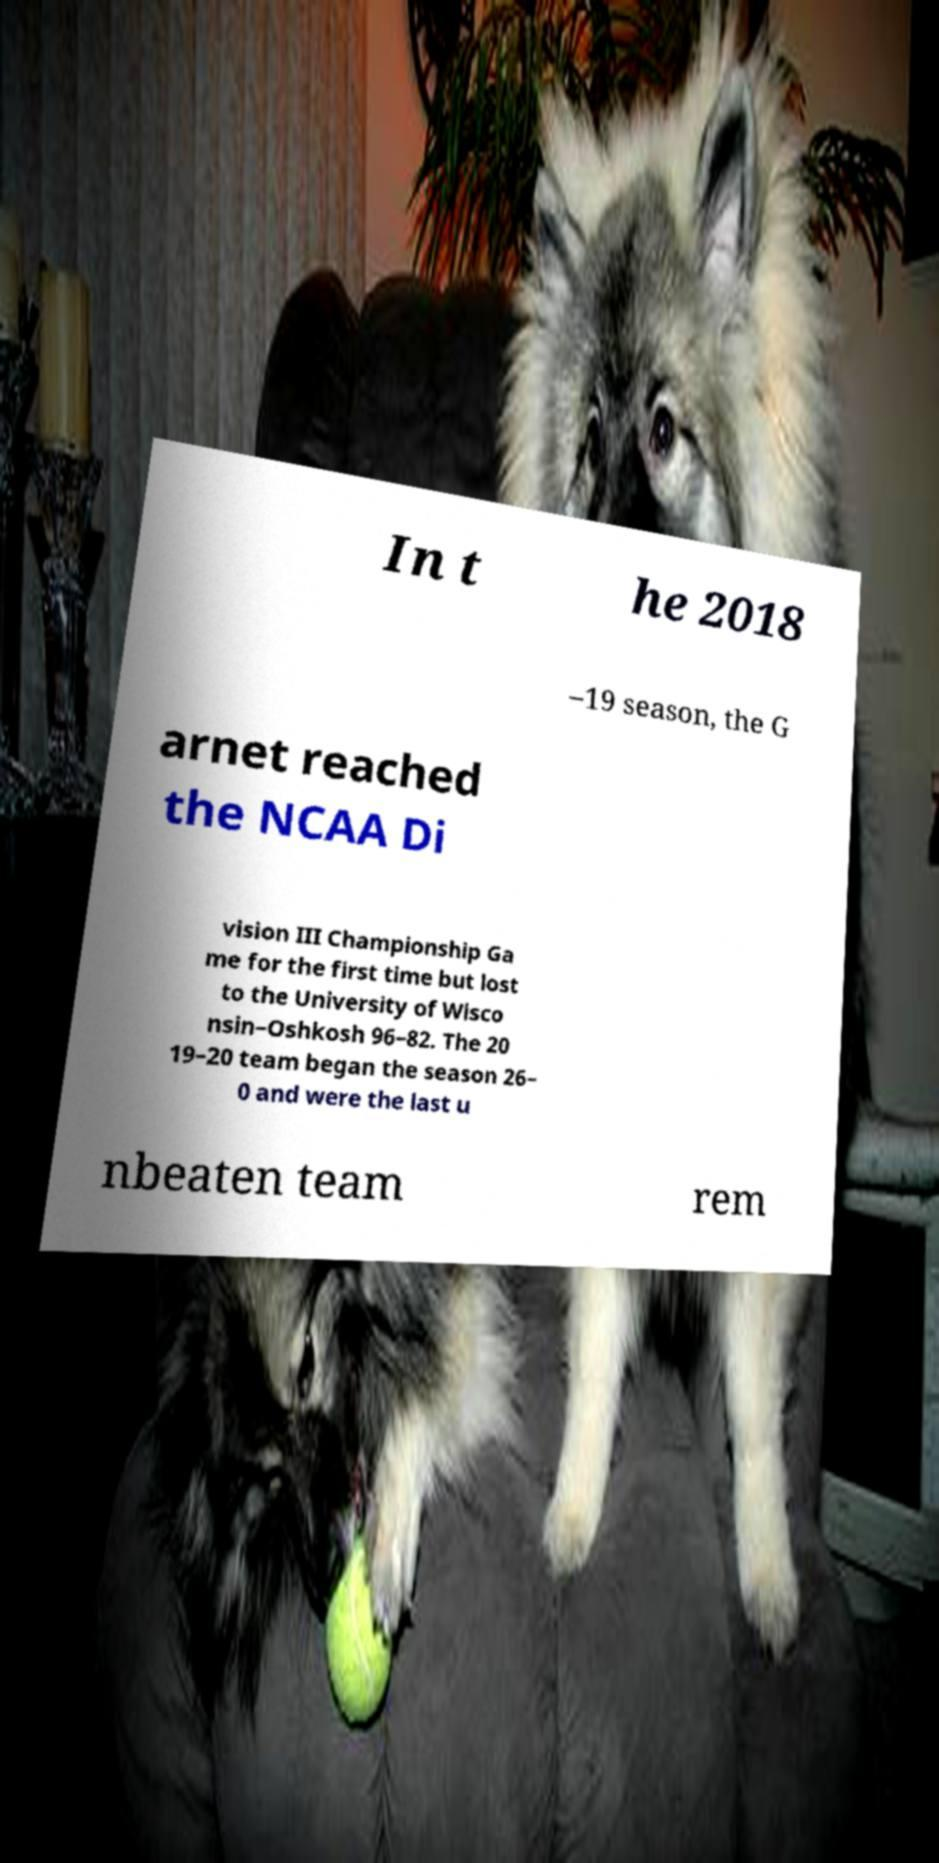Can you read and provide the text displayed in the image?This photo seems to have some interesting text. Can you extract and type it out for me? In t he 2018 –19 season, the G arnet reached the NCAA Di vision III Championship Ga me for the first time but lost to the University of Wisco nsin–Oshkosh 96–82. The 20 19–20 team began the season 26– 0 and were the last u nbeaten team rem 